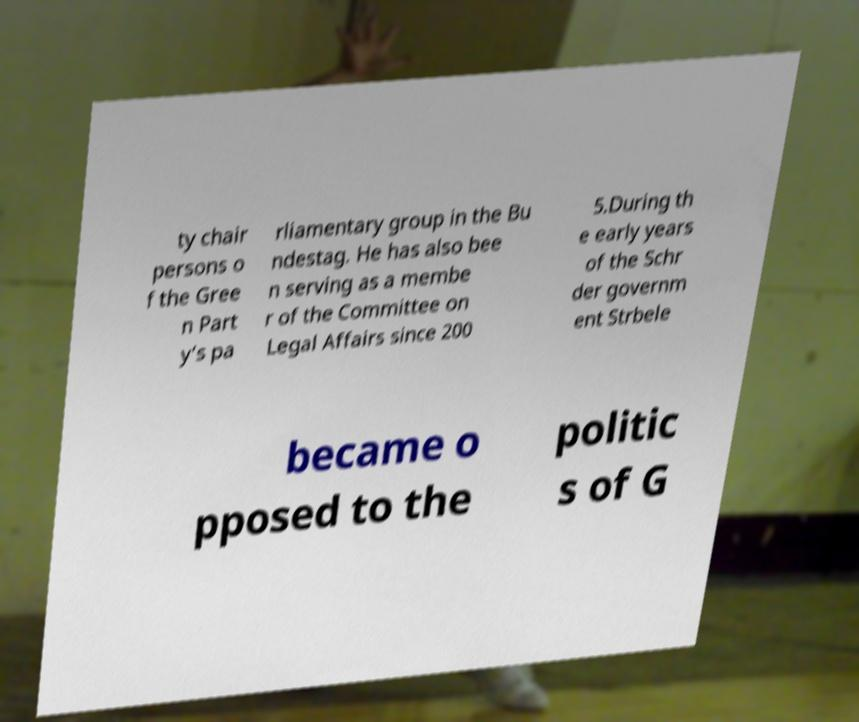What messages or text are displayed in this image? I need them in a readable, typed format. ty chair persons o f the Gree n Part y’s pa rliamentary group in the Bu ndestag. He has also bee n serving as a membe r of the Committee on Legal Affairs since 200 5.During th e early years of the Schr der governm ent Strbele became o pposed to the politic s of G 